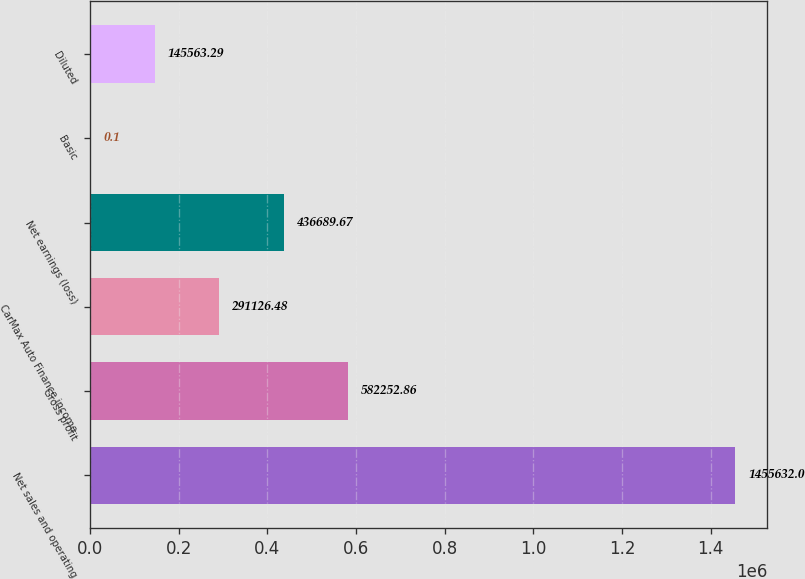Convert chart. <chart><loc_0><loc_0><loc_500><loc_500><bar_chart><fcel>Net sales and operating<fcel>Gross profit<fcel>CarMax Auto Finance income<fcel>Net earnings (loss)<fcel>Basic<fcel>Diluted<nl><fcel>1.45563e+06<fcel>582253<fcel>291126<fcel>436690<fcel>0.1<fcel>145563<nl></chart> 